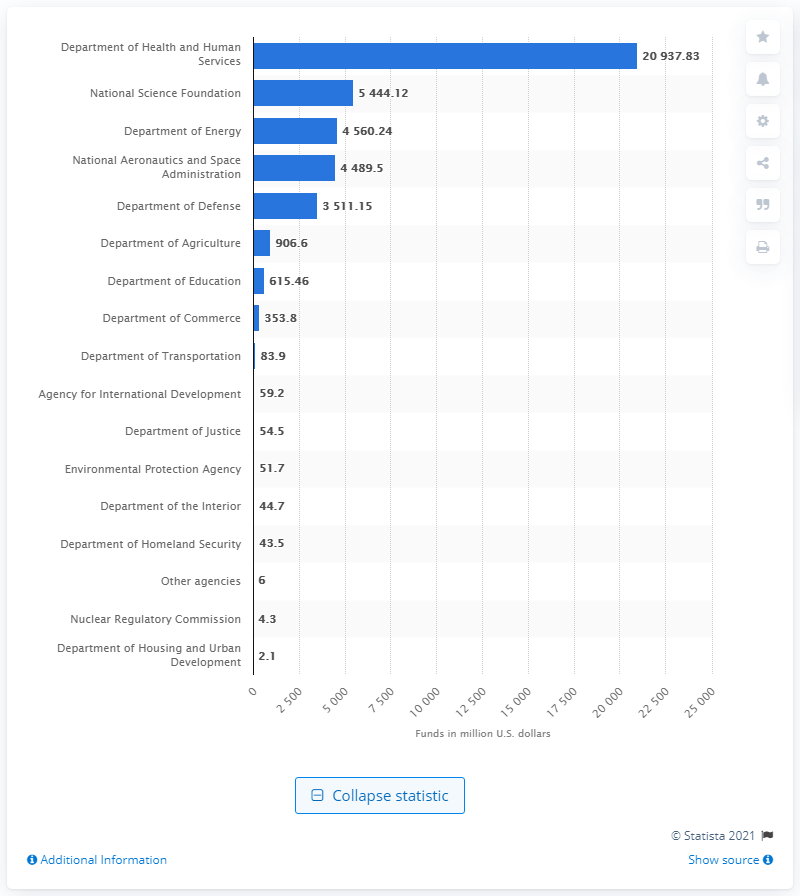Point out several critical features in this image. In 2019, the Department of Defense provided approximately $3511.15 in funding. 